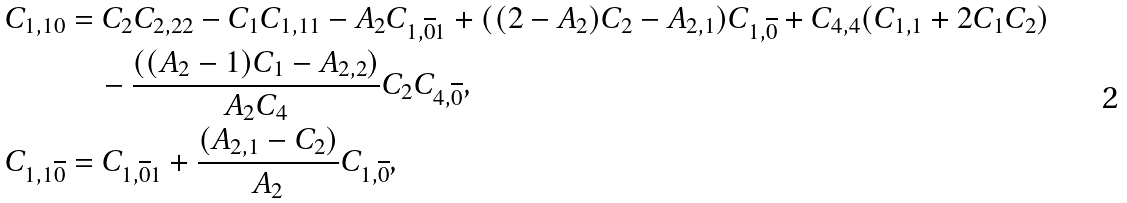Convert formula to latex. <formula><loc_0><loc_0><loc_500><loc_500>C _ { 1 , 1 0 } & = C _ { 2 } C _ { 2 , 2 2 } - C _ { 1 } C _ { 1 , 1 1 } - A _ { 2 } C _ { 1 , \overline { 0 } 1 } + ( ( 2 - A _ { 2 } ) C _ { 2 } - A _ { 2 , 1 } ) C _ { 1 , \overline { 0 } } + C _ { 4 , 4 } ( C _ { 1 , 1 } + 2 C _ { 1 } C _ { 2 } ) \\ & \quad - \frac { ( ( A _ { 2 } - 1 ) C _ { 1 } - A _ { 2 , 2 } ) } { A _ { 2 } C _ { 4 } } C _ { 2 } C _ { 4 , \overline { 0 } } , \\ C _ { 1 , 1 \overline { 0 } } & = C _ { 1 , \overline { 0 } 1 } + \frac { ( A _ { 2 , 1 } - C _ { 2 } ) } { A _ { 2 } } C _ { 1 , \overline { 0 } } ,</formula> 